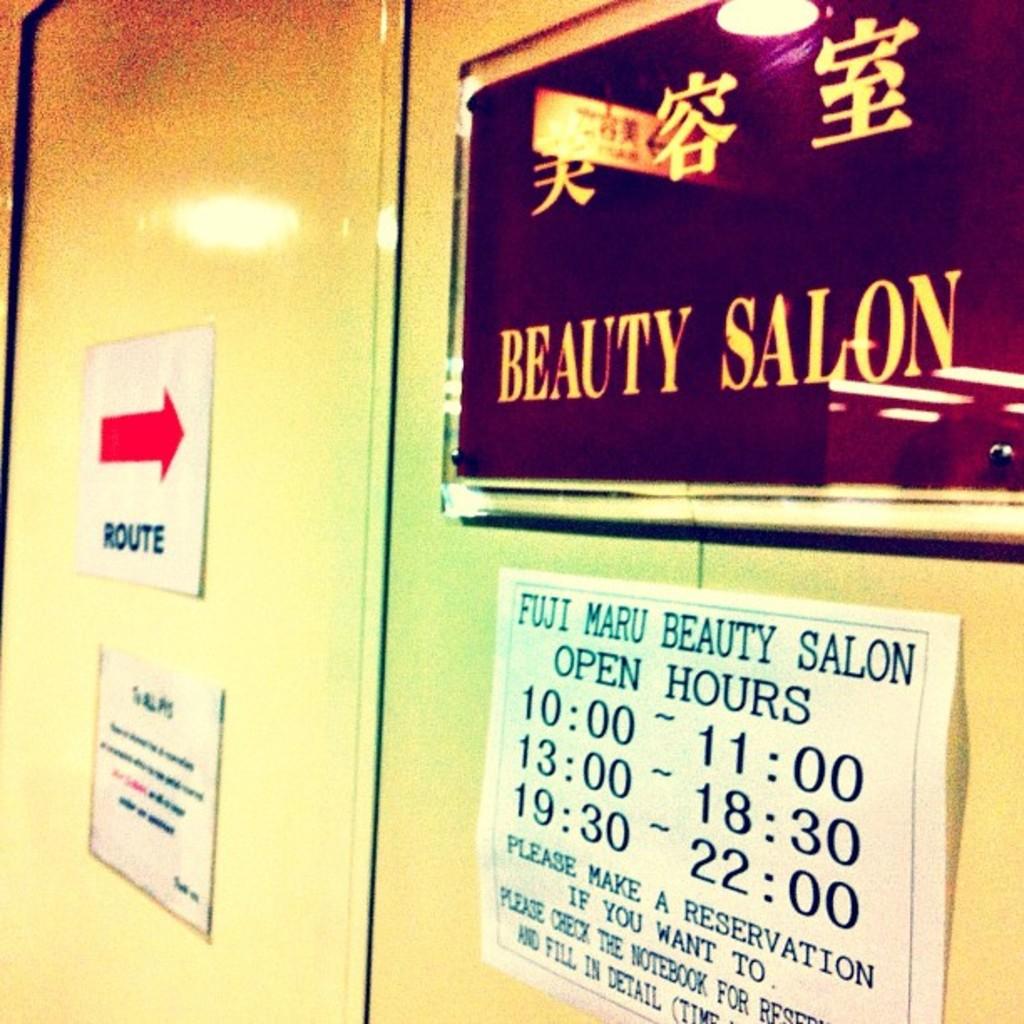What's the name of the salon?
Make the answer very short. Beauty salon. Can you make reservations?
Offer a very short reply. Yes. 